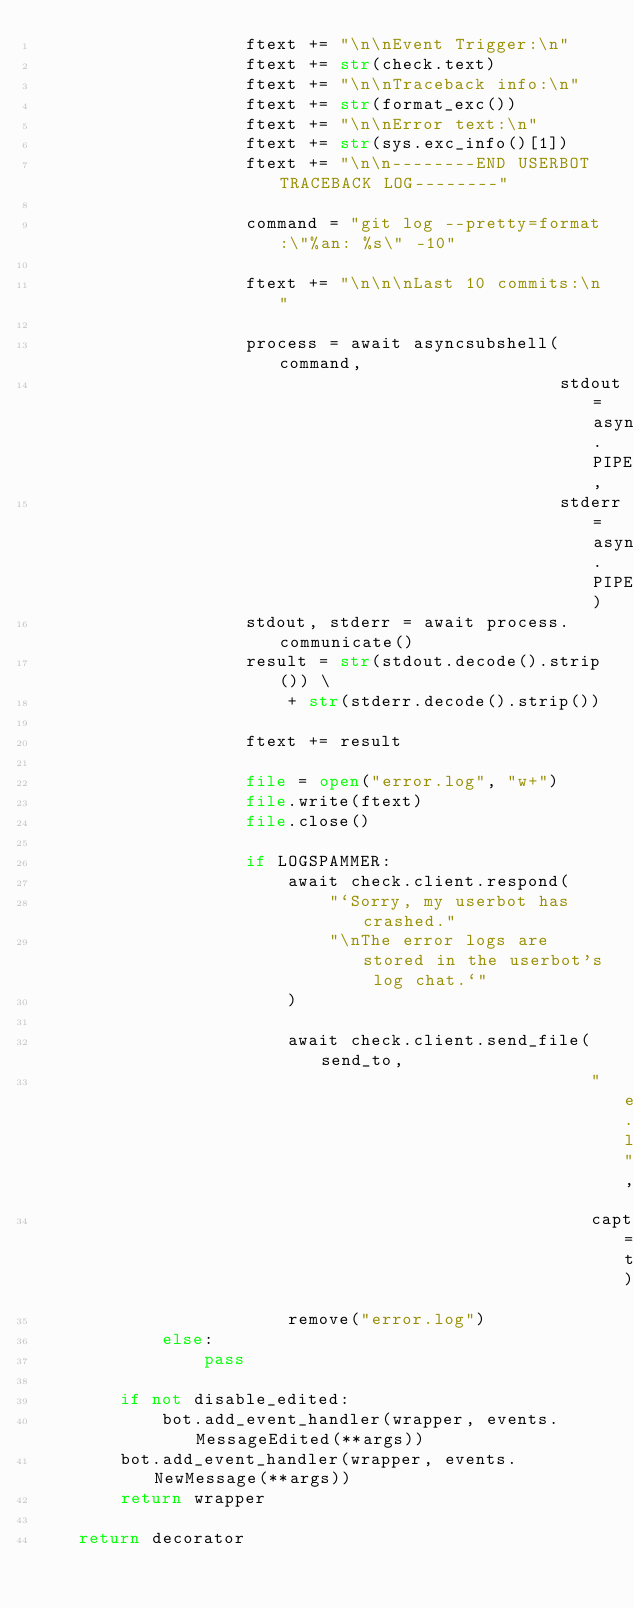<code> <loc_0><loc_0><loc_500><loc_500><_Python_>                    ftext += "\n\nEvent Trigger:\n"
                    ftext += str(check.text)
                    ftext += "\n\nTraceback info:\n"
                    ftext += str(format_exc())
                    ftext += "\n\nError text:\n"
                    ftext += str(sys.exc_info()[1])
                    ftext += "\n\n--------END USERBOT TRACEBACK LOG--------"

                    command = "git log --pretty=format:\"%an: %s\" -10"

                    ftext += "\n\n\nLast 10 commits:\n"

                    process = await asyncsubshell(command,
                                                  stdout=asyncsub.PIPE,
                                                  stderr=asyncsub.PIPE)
                    stdout, stderr = await process.communicate()
                    result = str(stdout.decode().strip()) \
                        + str(stderr.decode().strip())

                    ftext += result

                    file = open("error.log", "w+")
                    file.write(ftext)
                    file.close()

                    if LOGSPAMMER:
                        await check.client.respond(
                            "`Sorry, my userbot has crashed."
                            "\nThe error logs are stored in the userbot's log chat.`"
                        )

                        await check.client.send_file(send_to,
                                                     "error.log",
                                                     caption=text)
                        remove("error.log")
            else:
                pass

        if not disable_edited:
            bot.add_event_handler(wrapper, events.MessageEdited(**args))
        bot.add_event_handler(wrapper, events.NewMessage(**args))
        return wrapper

    return decorator
</code> 